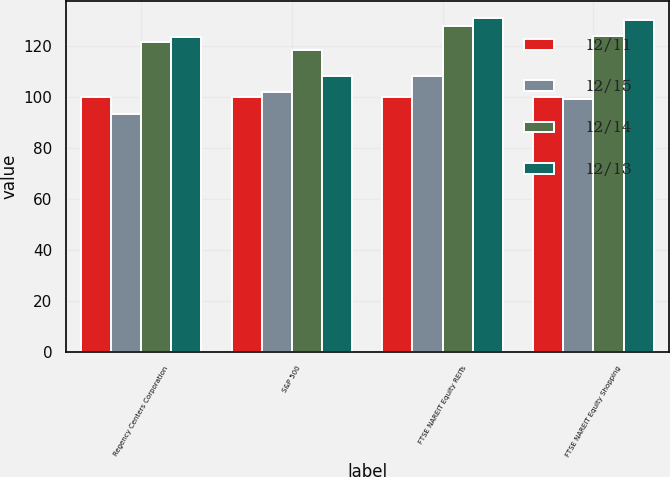Convert chart. <chart><loc_0><loc_0><loc_500><loc_500><stacked_bar_chart><ecel><fcel>Regency Centers Corporation<fcel>S&P 500<fcel>FTSE NAREIT Equity REITs<fcel>FTSE NAREIT Equity Shopping<nl><fcel>12/11<fcel>100<fcel>100<fcel>100<fcel>100<nl><fcel>12/15<fcel>93.15<fcel>102.11<fcel>108.29<fcel>99.27<nl><fcel>12/14<fcel>121.45<fcel>118.45<fcel>127.85<fcel>124.11<nl><fcel>12/13<fcel>123.64<fcel>108.29<fcel>131.01<fcel>130.31<nl></chart> 